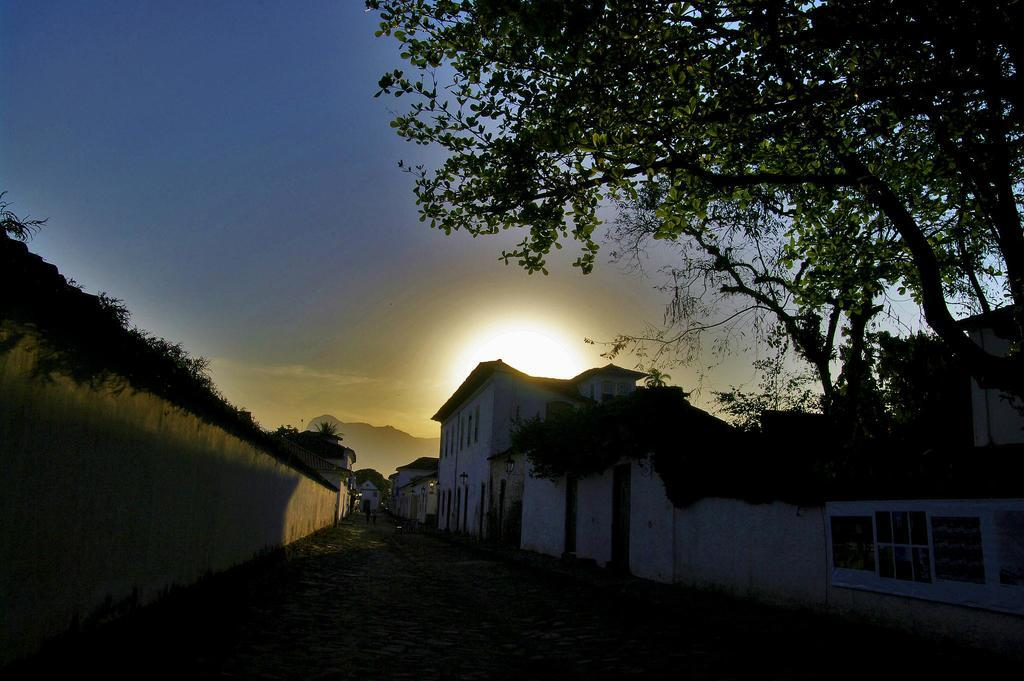What is located on the left side of the image? There is a wall on the left side of the image. What can be seen on the right side of the image? There are buildings on the right side of the image. What type of vegetation is present in the image? There are trees in the image. What is visible in the background of the image? There is a hill and the sky in the background of the image. Can the sun be seen in the image? Yes, the sun is observable in the sky. How many boots are visible on the hill in the image? There are no boots present in the image; it features a hill and trees in the background. What type of wrench is being used to repair the buildings in the image? There is no wrench or repair work being done in the image; it simply shows buildings, trees, and a hill in the background. 